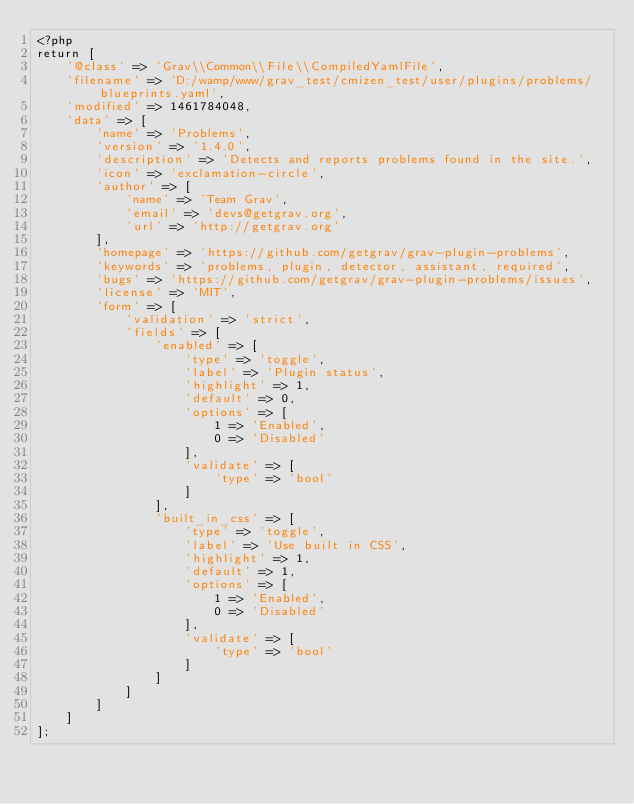Convert code to text. <code><loc_0><loc_0><loc_500><loc_500><_PHP_><?php
return [
    '@class' => 'Grav\\Common\\File\\CompiledYamlFile',
    'filename' => 'D:/wamp/www/grav_test/cmizen_test/user/plugins/problems/blueprints.yaml',
    'modified' => 1461784048,
    'data' => [
        'name' => 'Problems',
        'version' => '1.4.0',
        'description' => 'Detects and reports problems found in the site.',
        'icon' => 'exclamation-circle',
        'author' => [
            'name' => 'Team Grav',
            'email' => 'devs@getgrav.org',
            'url' => 'http://getgrav.org'
        ],
        'homepage' => 'https://github.com/getgrav/grav-plugin-problems',
        'keywords' => 'problems, plugin, detector, assistant, required',
        'bugs' => 'https://github.com/getgrav/grav-plugin-problems/issues',
        'license' => 'MIT',
        'form' => [
            'validation' => 'strict',
            'fields' => [
                'enabled' => [
                    'type' => 'toggle',
                    'label' => 'Plugin status',
                    'highlight' => 1,
                    'default' => 0,
                    'options' => [
                        1 => 'Enabled',
                        0 => 'Disabled'
                    ],
                    'validate' => [
                        'type' => 'bool'
                    ]
                ],
                'built_in_css' => [
                    'type' => 'toggle',
                    'label' => 'Use built in CSS',
                    'highlight' => 1,
                    'default' => 1,
                    'options' => [
                        1 => 'Enabled',
                        0 => 'Disabled'
                    ],
                    'validate' => [
                        'type' => 'bool'
                    ]
                ]
            ]
        ]
    ]
];
</code> 